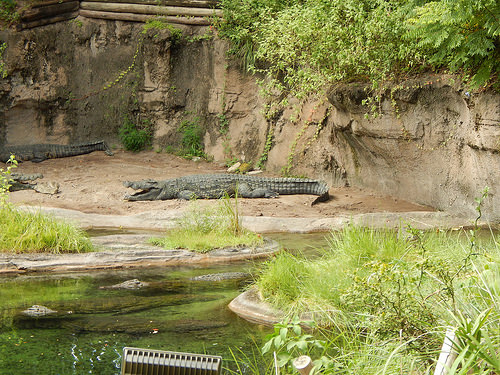<image>
Can you confirm if the water is under the crocodile? No. The water is not positioned under the crocodile. The vertical relationship between these objects is different. 